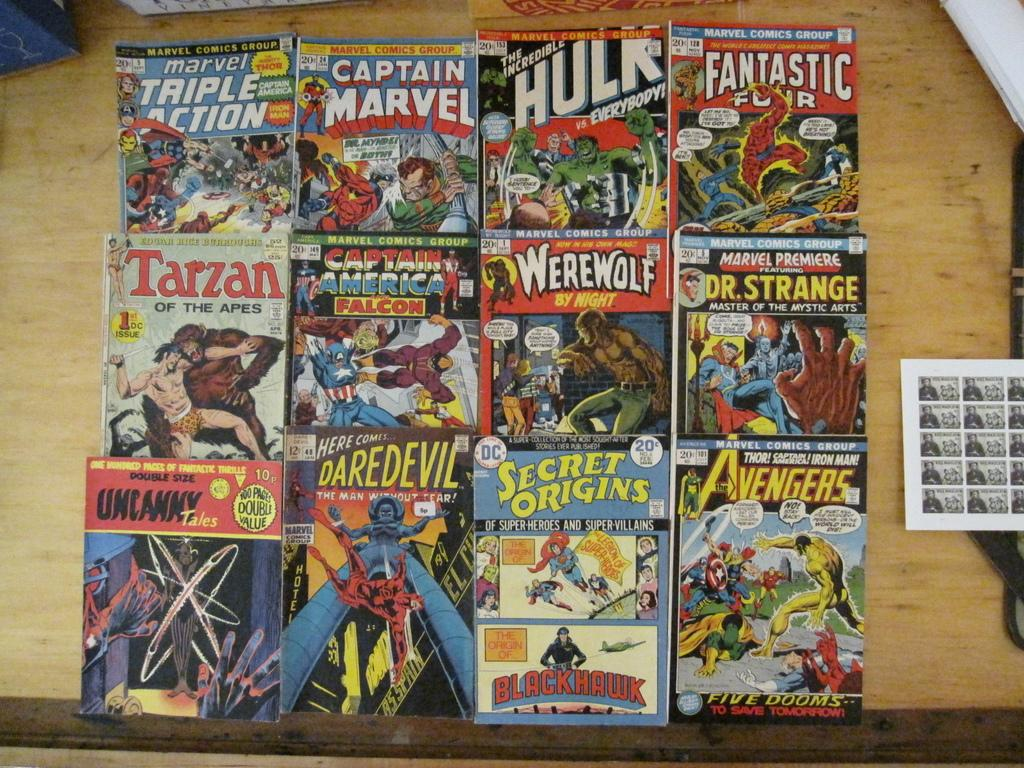<image>
Relay a brief, clear account of the picture shown. Twelve different comics are arranged including The Fantastic four and Dr. Strange. 